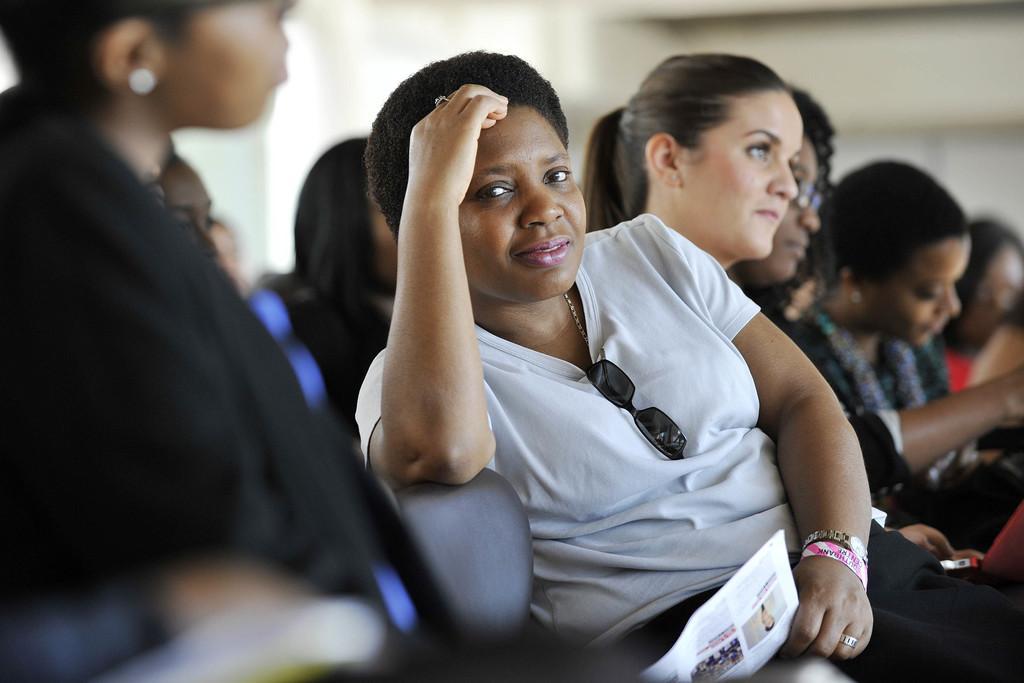How would you summarize this image in a sentence or two? There is a group of persons sitting on the chairs as we can see in the middle of this image. The person sitting in the middle is wearing a white color t shirt and holding a paper. 